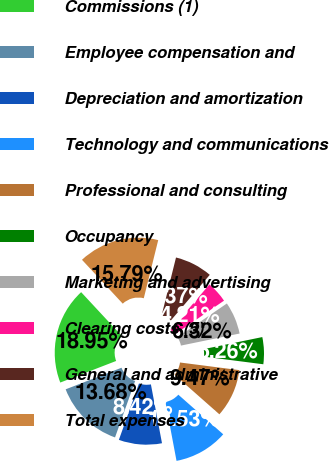<chart> <loc_0><loc_0><loc_500><loc_500><pie_chart><fcel>Commissions (1)<fcel>Employee compensation and<fcel>Depreciation and amortization<fcel>Technology and communications<fcel>Professional and consulting<fcel>Occupancy<fcel>Marketing and advertising<fcel>Clearing costs (5)<fcel>General and administrative<fcel>Total expenses<nl><fcel>18.95%<fcel>13.68%<fcel>8.42%<fcel>10.53%<fcel>9.47%<fcel>5.26%<fcel>6.32%<fcel>4.21%<fcel>7.37%<fcel>15.79%<nl></chart> 